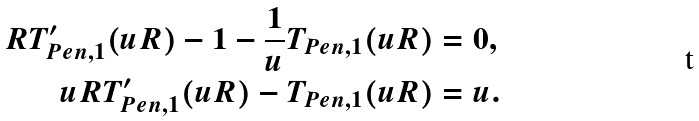<formula> <loc_0><loc_0><loc_500><loc_500>R T _ { P e n , 1 } ^ { \prime } ( u R ) - 1 - \frac { 1 } { u } T _ { P e n , 1 } ( u R ) & = 0 , \\ u R T _ { P e n , 1 } ^ { \prime } ( u R ) - T _ { P e n , 1 } ( u R ) & = u .</formula> 